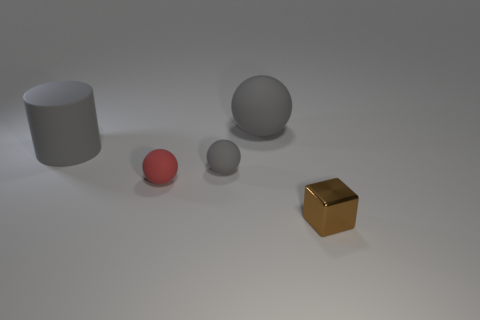There is another rubber ball that is the same color as the large matte ball; what size is it?
Make the answer very short. Small. There is a gray cylinder that is the same material as the red sphere; what is its size?
Ensure brevity in your answer.  Large. There is a matte object that is in front of the tiny gray rubber sphere; is its size the same as the brown metallic thing that is to the right of the big ball?
Offer a very short reply. Yes. What number of things are either matte objects or yellow shiny cylinders?
Your answer should be compact. 4. What is the shape of the tiny red object?
Give a very brief answer. Sphere. There is another gray matte thing that is the same shape as the small gray matte object; what size is it?
Ensure brevity in your answer.  Large. Is there any other thing that has the same material as the small brown thing?
Offer a very short reply. No. How big is the gray ball that is in front of the large matte thing behind the big cylinder?
Your answer should be very brief. Small. Are there an equal number of tiny red things behind the red rubber ball and small brown objects?
Offer a terse response. No. What number of other objects are the same color as the metallic thing?
Offer a terse response. 0. 